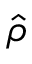<formula> <loc_0><loc_0><loc_500><loc_500>\hat { \rho }</formula> 